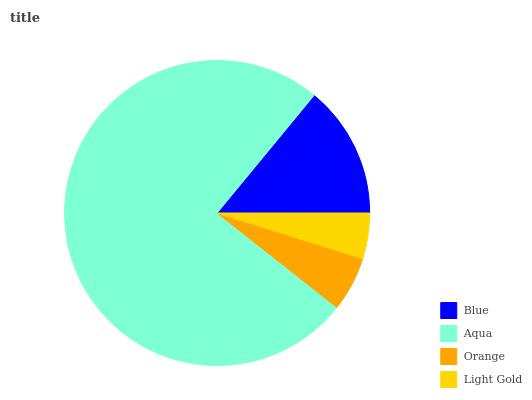Is Light Gold the minimum?
Answer yes or no. Yes. Is Aqua the maximum?
Answer yes or no. Yes. Is Orange the minimum?
Answer yes or no. No. Is Orange the maximum?
Answer yes or no. No. Is Aqua greater than Orange?
Answer yes or no. Yes. Is Orange less than Aqua?
Answer yes or no. Yes. Is Orange greater than Aqua?
Answer yes or no. No. Is Aqua less than Orange?
Answer yes or no. No. Is Blue the high median?
Answer yes or no. Yes. Is Orange the low median?
Answer yes or no. Yes. Is Aqua the high median?
Answer yes or no. No. Is Light Gold the low median?
Answer yes or no. No. 